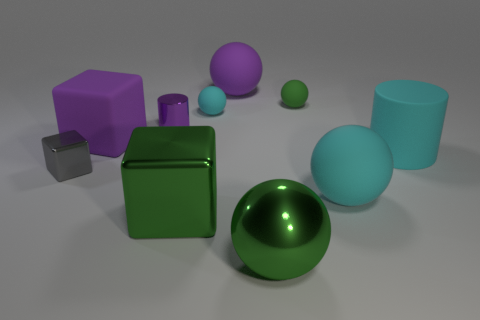There is a rubber block that is in front of the purple cylinder; does it have the same color as the metallic cylinder?
Your answer should be very brief. Yes. Is there a shiny ball of the same size as the purple rubber sphere?
Keep it short and to the point. Yes. Are there fewer green blocks than rubber objects?
Ensure brevity in your answer.  Yes. The big purple object on the left side of the big green metal object that is behind the thing that is in front of the large metal cube is what shape?
Your response must be concise. Cube. What number of objects are either cyan things that are on the left side of the large cyan matte sphere or large purple rubber objects behind the tiny purple metallic cylinder?
Your answer should be compact. 2. There is a small purple metallic cylinder; are there any small balls on the left side of it?
Your response must be concise. No. What number of things are large things in front of the big purple ball or green matte blocks?
Provide a short and direct response. 5. What number of cyan things are blocks or tiny matte objects?
Provide a succinct answer. 1. What number of other objects are there of the same color as the metal sphere?
Provide a succinct answer. 2. Is the number of small purple metal objects that are in front of the small purple thing less than the number of small purple cylinders?
Provide a succinct answer. Yes. 